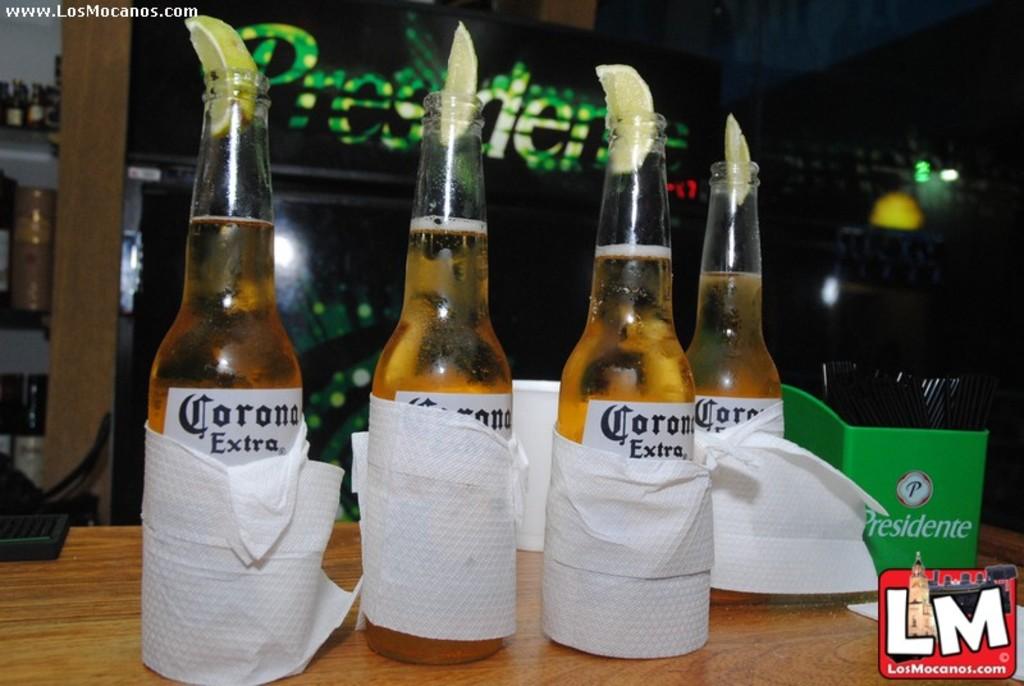What kind of beer is in the bottles?
Ensure brevity in your answer.  Corona. What beer brand is shown on the green box?
Offer a terse response. Presidente. 